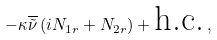<formula> <loc_0><loc_0><loc_500><loc_500>- \kappa \overline { \tilde { \nu } } \left ( i N _ { 1 r } + N _ { 2 r } \right ) + \text {h.c.} \, ,</formula> 